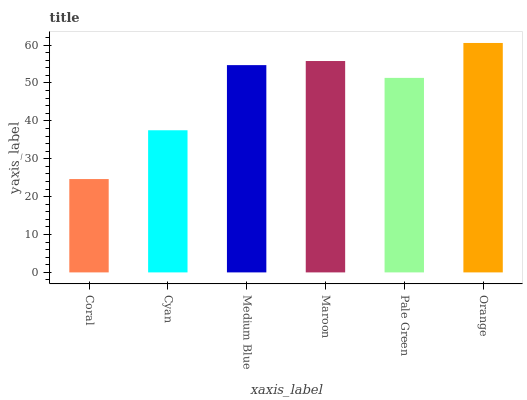Is Coral the minimum?
Answer yes or no. Yes. Is Orange the maximum?
Answer yes or no. Yes. Is Cyan the minimum?
Answer yes or no. No. Is Cyan the maximum?
Answer yes or no. No. Is Cyan greater than Coral?
Answer yes or no. Yes. Is Coral less than Cyan?
Answer yes or no. Yes. Is Coral greater than Cyan?
Answer yes or no. No. Is Cyan less than Coral?
Answer yes or no. No. Is Medium Blue the high median?
Answer yes or no. Yes. Is Pale Green the low median?
Answer yes or no. Yes. Is Cyan the high median?
Answer yes or no. No. Is Cyan the low median?
Answer yes or no. No. 